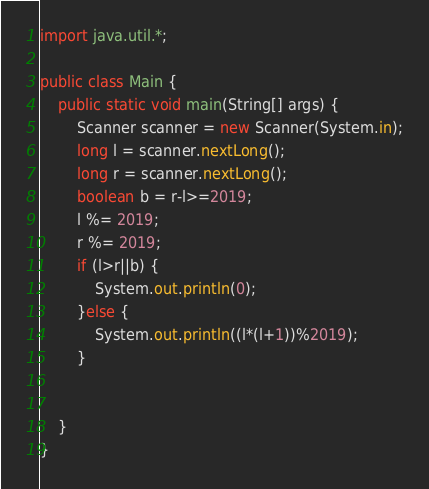Convert code to text. <code><loc_0><loc_0><loc_500><loc_500><_Java_>import java.util.*;

public class Main {
    public static void main(String[] args) {
        Scanner scanner = new Scanner(System.in);
        long l = scanner.nextLong();
        long r = scanner.nextLong();
        boolean b = r-l>=2019;
        l %= 2019;
        r %= 2019;
        if (l>r||b) {
            System.out.println(0);
        }else {
            System.out.println((l*(l+1))%2019);
        }


    }
}
</code> 